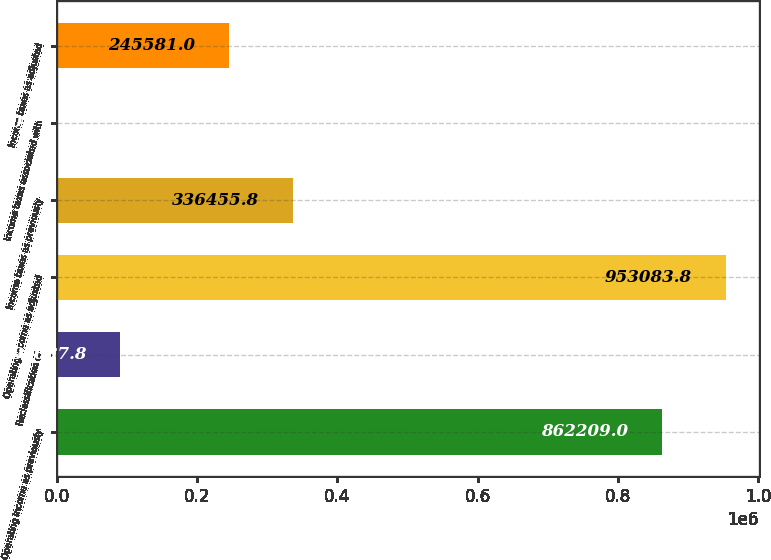<chart> <loc_0><loc_0><loc_500><loc_500><bar_chart><fcel>Operating income as previously<fcel>Reclassification of<fcel>Operating income as adjusted<fcel>Income taxes as previously<fcel>Income taxes associated with<fcel>Income taxes as adjusted<nl><fcel>862209<fcel>91037.8<fcel>953084<fcel>336456<fcel>163<fcel>245581<nl></chart> 